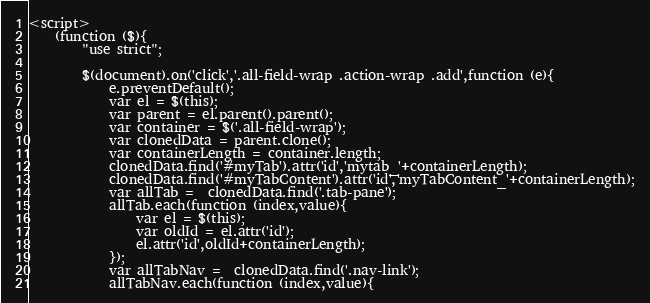<code> <loc_0><loc_0><loc_500><loc_500><_PHP_><script>
    (function ($){
        "use strict";

        $(document).on('click','.all-field-wrap .action-wrap .add',function (e){
            e.preventDefault();
            var el = $(this);
            var parent = el.parent().parent();
            var container = $('.all-field-wrap');
            var clonedData = parent.clone();
            var containerLength = container.length;
            clonedData.find('#myTab').attr('id','mytab_'+containerLength);
            clonedData.find('#myTabContent').attr('id','myTabContent_'+containerLength);
            var allTab =  clonedData.find('.tab-pane');
            allTab.each(function (index,value){
                var el = $(this);
                var oldId = el.attr('id');
                el.attr('id',oldId+containerLength);
            });
            var allTabNav =  clonedData.find('.nav-link');
            allTabNav.each(function (index,value){</code> 